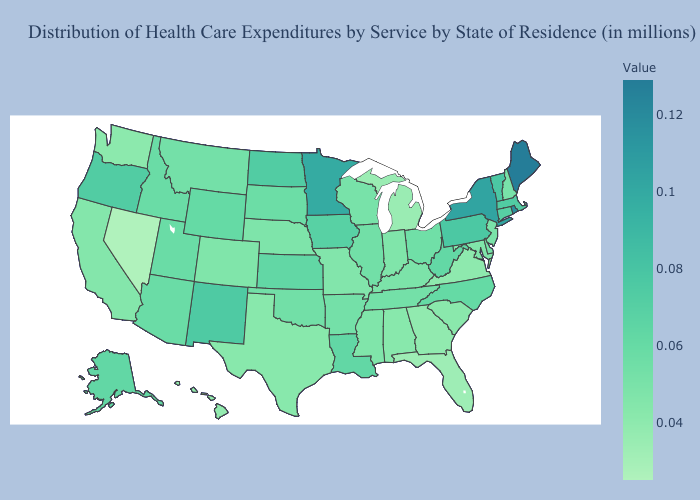Does Texas have a lower value than Nevada?
Answer briefly. No. Does the map have missing data?
Concise answer only. No. Does Nevada have the lowest value in the USA?
Short answer required. Yes. 